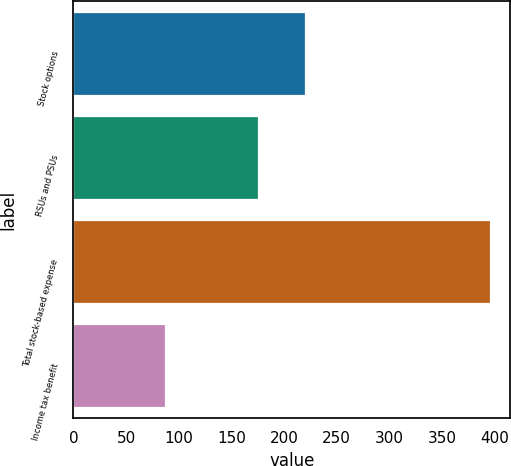<chart> <loc_0><loc_0><loc_500><loc_500><bar_chart><fcel>Stock options<fcel>RSUs and PSUs<fcel>Total stock-based expense<fcel>Income tax benefit<nl><fcel>220<fcel>175<fcel>395<fcel>87<nl></chart> 